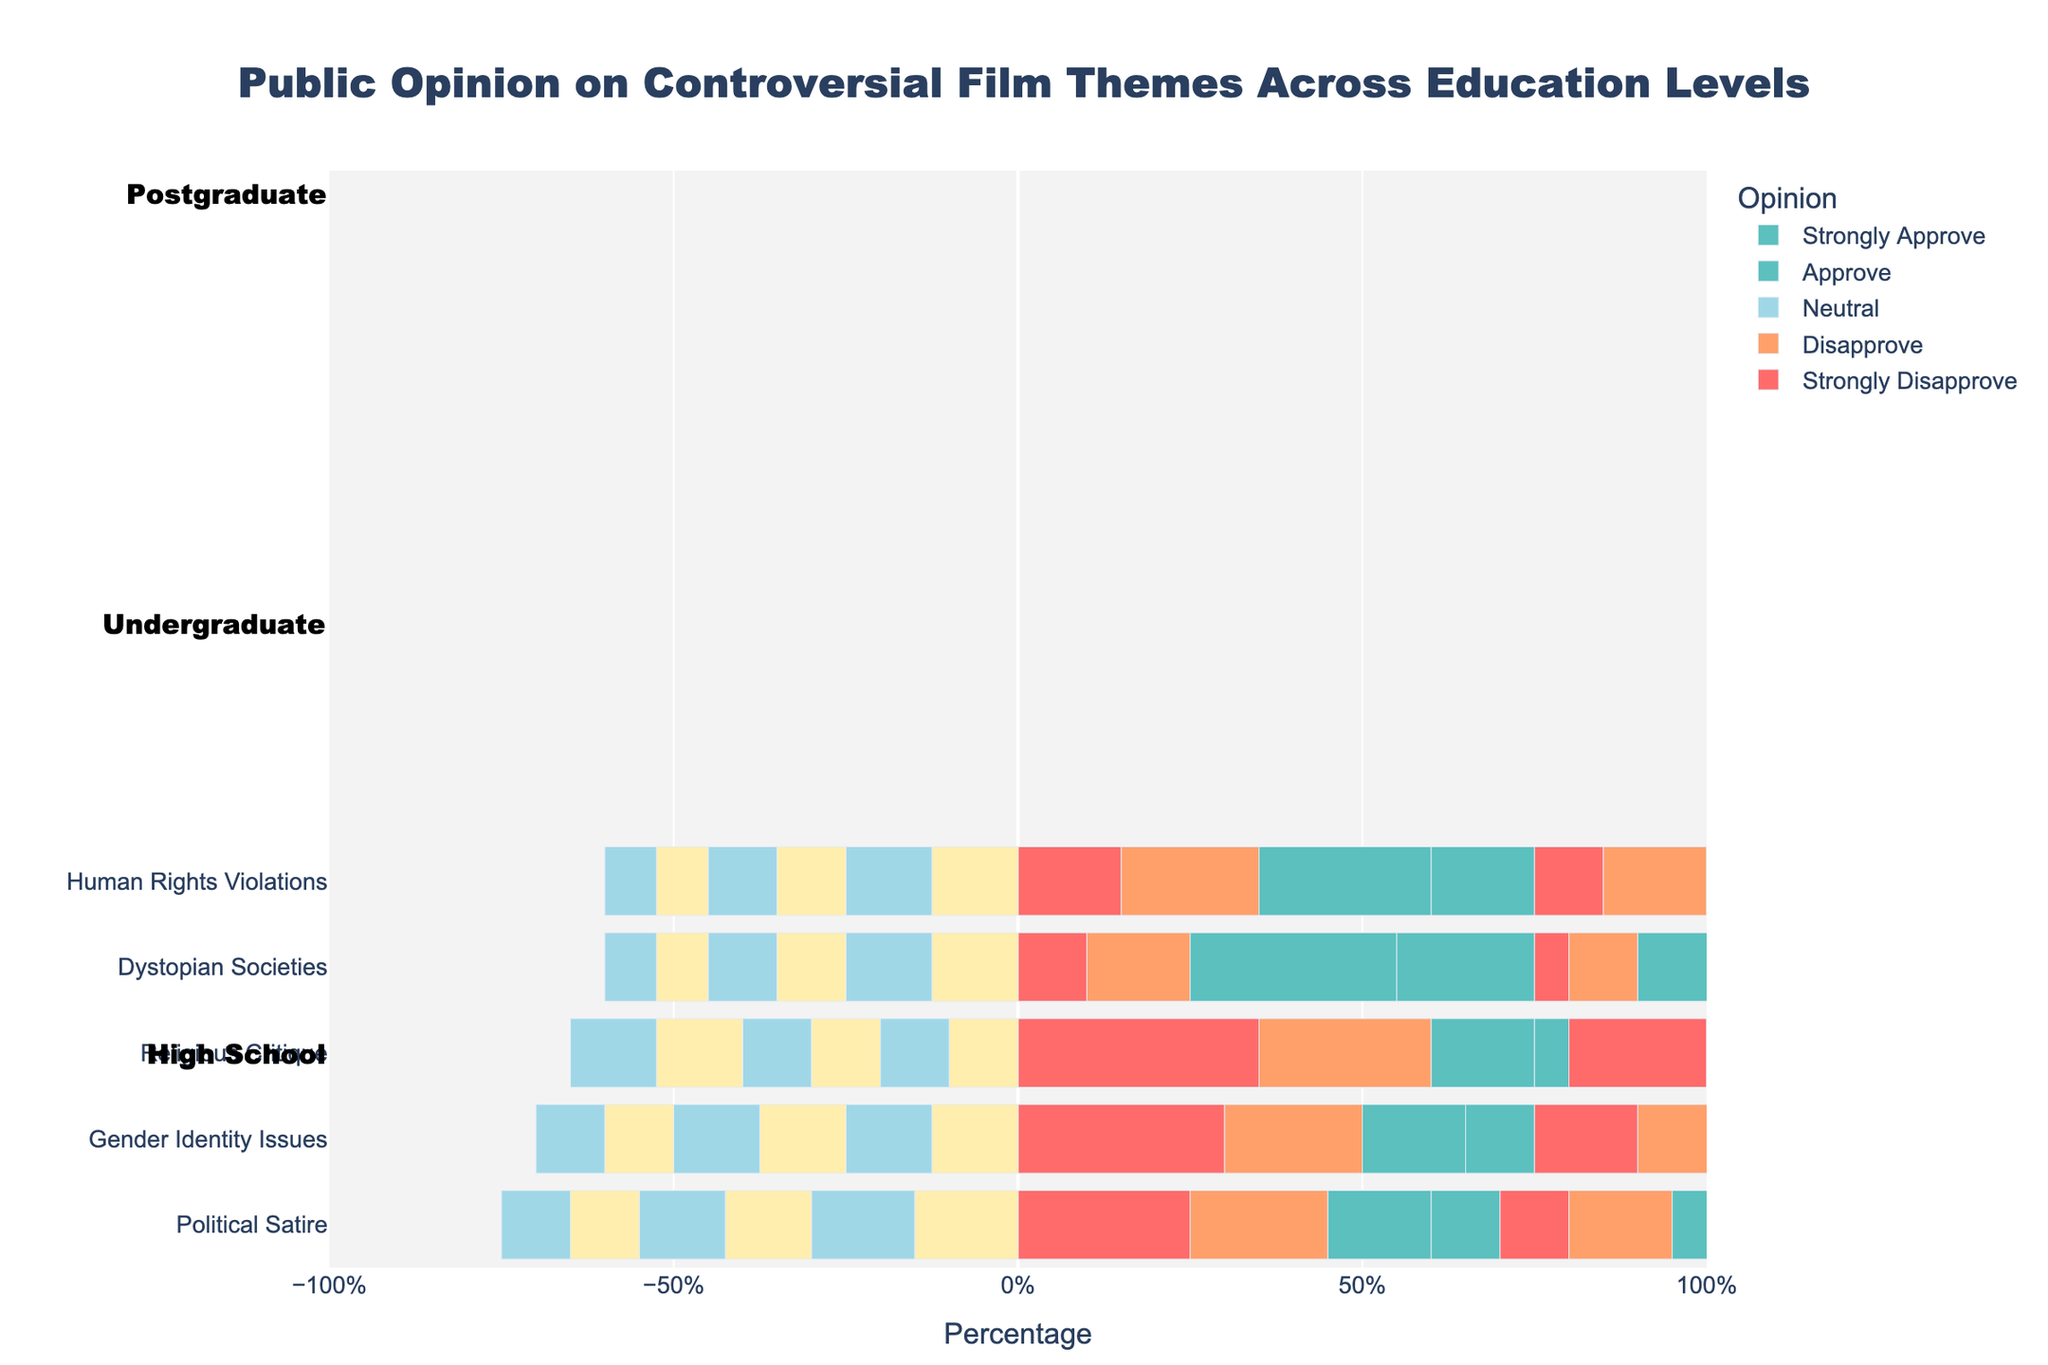Which education level has the highest approval (Approve + Strongly Approve) for Dystopian Societies? We need to check the bars for "Approve" and "Strongly Approve" for the theme "Dystopian Societies" across all education levels and sum them up. The highest total belongs to the postgraduate level (35% + 40% = 75%).
Answer: Postgraduate Which theme has the highest disapproval (Strongly Disapprove + Disapprove) in the high school education level? We need to add up the "Strongly Disapprove" and "Disapprove" percentages for all themes in the high school education level. "Religious Critique" (35% + 25% = 60%) has the highest disapproval.
Answer: Religious Critique Does the undergraduate level have a more favorable opinion on Political Satire or Gender Identity Issues? Compare the sum of "Approve" and "Strongly Approve" for both themes in the undergraduate level. Political Satire: 30% + 20% = 50%. Gender Identity Issues: 25% + 15% = 40%. Political Satire has the more favorable opinion.
Answer: Political Satire Is the neutral opinion on Human Rights Violations higher in high school or undergraduate? Check the "Neutral" bar percentage for "Human Rights Violations" in both education levels. High school's neutral is 25%, while undergraduate's is 20%. High school is higher.
Answer: High school Which has a higher combined approval (Approve + Strongly Approve), Political Satire in the undergraduate level or Religious Critique in the postgraduate level? Add up "Approve" and "Strongly Approve" for both themes in the respective education levels. Political Satire (undergraduate): 30% + 20% = 50%. Religious Critique (postgraduate): 25% + 20% = 45%. Political Satire (undergraduate) has the higher combined approval.
Answer: Political Satire (undergraduate) Which education level has the highest proportion of neutral opinion overall? To find the education level with the highest total neutral opinion, sum up the "Neutral" percentages for each education level across all themes. Postgraduate level often has the lowest neutral values, while high school generally has higher neutrals across themes. Detailed calculation shows high school has the overall highest neutrals.
Answer: High school How does approval (Approve + Strongly Approve) for Gender Identity Issues compare between high school and postgraduate levels? Sum the "Approve" and "Strongly Approve" percentages for Gender Identity Issues in both levels. High school: 15% + 10% = 25%. Postgraduate: 30% + 25% = 55%. Postgraduate level has a higher approval.
Answer: Postgraduate What is the overall trend in opinion towards Religious Critique across education levels? By looking at the bars for "Strongly Disapprove" to "Strongly Approve" for Religious Critique across all education levels, there is a clear trend of decreasing disapproval and increasing approval as the education level increases. This indicates that higher education levels tend to approve more and disapprove less of Religious Critique.
Answer: Increasing approval with higher education levels 